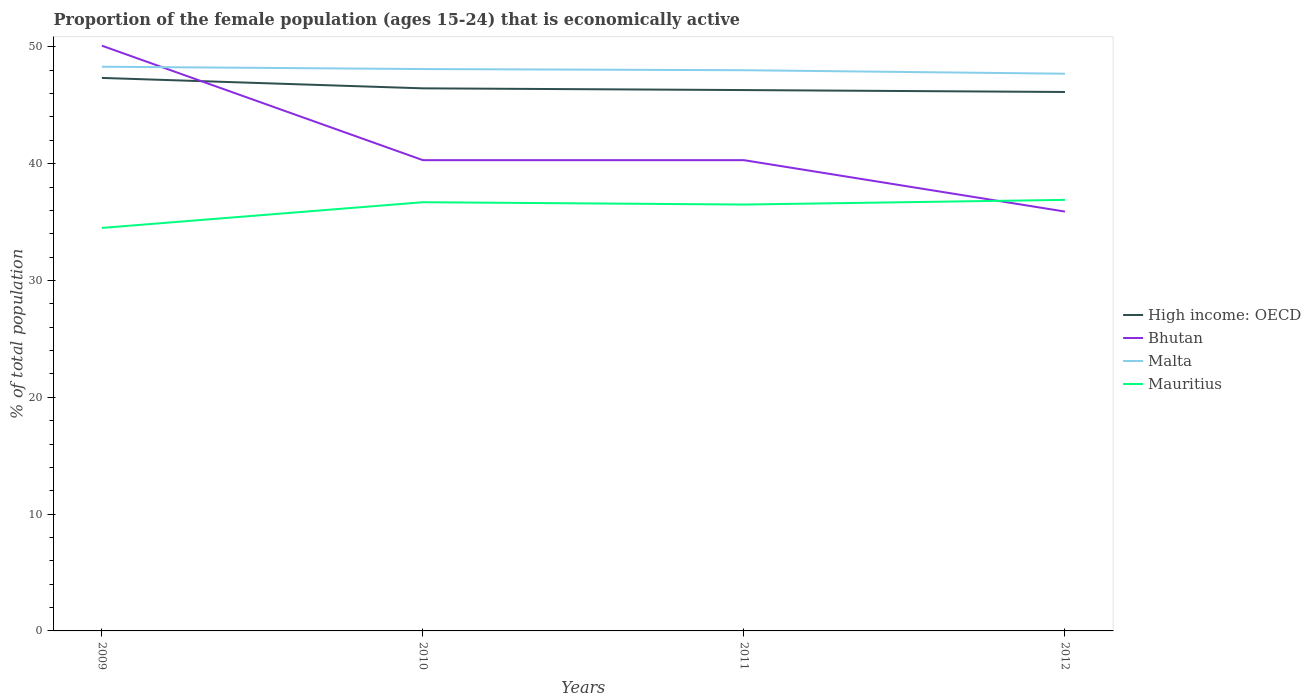How many different coloured lines are there?
Your answer should be very brief. 4. Does the line corresponding to Mauritius intersect with the line corresponding to Malta?
Provide a short and direct response. No. Across all years, what is the maximum proportion of the female population that is economically active in Mauritius?
Make the answer very short. 34.5. What is the total proportion of the female population that is economically active in Bhutan in the graph?
Your answer should be very brief. 9.8. What is the difference between the highest and the second highest proportion of the female population that is economically active in High income: OECD?
Provide a succinct answer. 1.2. Is the proportion of the female population that is economically active in Malta strictly greater than the proportion of the female population that is economically active in High income: OECD over the years?
Offer a very short reply. No. How many lines are there?
Your answer should be very brief. 4. Does the graph contain any zero values?
Your answer should be very brief. No. Where does the legend appear in the graph?
Ensure brevity in your answer.  Center right. What is the title of the graph?
Your answer should be compact. Proportion of the female population (ages 15-24) that is economically active. What is the label or title of the X-axis?
Your answer should be very brief. Years. What is the label or title of the Y-axis?
Offer a very short reply. % of total population. What is the % of total population in High income: OECD in 2009?
Provide a short and direct response. 47.34. What is the % of total population of Bhutan in 2009?
Give a very brief answer. 50.1. What is the % of total population in Malta in 2009?
Provide a succinct answer. 48.3. What is the % of total population of Mauritius in 2009?
Your answer should be very brief. 34.5. What is the % of total population in High income: OECD in 2010?
Offer a very short reply. 46.45. What is the % of total population of Bhutan in 2010?
Offer a terse response. 40.3. What is the % of total population in Malta in 2010?
Keep it short and to the point. 48.1. What is the % of total population of Mauritius in 2010?
Provide a succinct answer. 36.7. What is the % of total population in High income: OECD in 2011?
Offer a very short reply. 46.3. What is the % of total population of Bhutan in 2011?
Your answer should be very brief. 40.3. What is the % of total population in Mauritius in 2011?
Your response must be concise. 36.5. What is the % of total population of High income: OECD in 2012?
Offer a terse response. 46.14. What is the % of total population in Bhutan in 2012?
Provide a succinct answer. 35.9. What is the % of total population in Malta in 2012?
Ensure brevity in your answer.  47.7. What is the % of total population of Mauritius in 2012?
Your response must be concise. 36.9. Across all years, what is the maximum % of total population of High income: OECD?
Keep it short and to the point. 47.34. Across all years, what is the maximum % of total population of Bhutan?
Your response must be concise. 50.1. Across all years, what is the maximum % of total population in Malta?
Provide a succinct answer. 48.3. Across all years, what is the maximum % of total population of Mauritius?
Your answer should be very brief. 36.9. Across all years, what is the minimum % of total population in High income: OECD?
Offer a terse response. 46.14. Across all years, what is the minimum % of total population of Bhutan?
Provide a succinct answer. 35.9. Across all years, what is the minimum % of total population of Malta?
Ensure brevity in your answer.  47.7. Across all years, what is the minimum % of total population of Mauritius?
Make the answer very short. 34.5. What is the total % of total population of High income: OECD in the graph?
Give a very brief answer. 186.23. What is the total % of total population of Bhutan in the graph?
Keep it short and to the point. 166.6. What is the total % of total population in Malta in the graph?
Keep it short and to the point. 192.1. What is the total % of total population in Mauritius in the graph?
Keep it short and to the point. 144.6. What is the difference between the % of total population of High income: OECD in 2009 and that in 2010?
Provide a short and direct response. 0.89. What is the difference between the % of total population in High income: OECD in 2009 and that in 2011?
Make the answer very short. 1.04. What is the difference between the % of total population of High income: OECD in 2009 and that in 2012?
Your response must be concise. 1.2. What is the difference between the % of total population of Bhutan in 2009 and that in 2012?
Your response must be concise. 14.2. What is the difference between the % of total population of Mauritius in 2009 and that in 2012?
Offer a very short reply. -2.4. What is the difference between the % of total population of High income: OECD in 2010 and that in 2011?
Offer a very short reply. 0.15. What is the difference between the % of total population in Mauritius in 2010 and that in 2011?
Give a very brief answer. 0.2. What is the difference between the % of total population of High income: OECD in 2010 and that in 2012?
Your response must be concise. 0.31. What is the difference between the % of total population of Malta in 2010 and that in 2012?
Provide a succinct answer. 0.4. What is the difference between the % of total population of High income: OECD in 2011 and that in 2012?
Provide a short and direct response. 0.16. What is the difference between the % of total population of Bhutan in 2011 and that in 2012?
Give a very brief answer. 4.4. What is the difference between the % of total population of High income: OECD in 2009 and the % of total population of Bhutan in 2010?
Give a very brief answer. 7.04. What is the difference between the % of total population of High income: OECD in 2009 and the % of total population of Malta in 2010?
Provide a succinct answer. -0.76. What is the difference between the % of total population in High income: OECD in 2009 and the % of total population in Mauritius in 2010?
Ensure brevity in your answer.  10.64. What is the difference between the % of total population in Bhutan in 2009 and the % of total population in Mauritius in 2010?
Provide a short and direct response. 13.4. What is the difference between the % of total population in High income: OECD in 2009 and the % of total population in Bhutan in 2011?
Give a very brief answer. 7.04. What is the difference between the % of total population in High income: OECD in 2009 and the % of total population in Malta in 2011?
Keep it short and to the point. -0.66. What is the difference between the % of total population in High income: OECD in 2009 and the % of total population in Mauritius in 2011?
Keep it short and to the point. 10.84. What is the difference between the % of total population in Bhutan in 2009 and the % of total population in Malta in 2011?
Offer a very short reply. 2.1. What is the difference between the % of total population of Malta in 2009 and the % of total population of Mauritius in 2011?
Your response must be concise. 11.8. What is the difference between the % of total population in High income: OECD in 2009 and the % of total population in Bhutan in 2012?
Your response must be concise. 11.44. What is the difference between the % of total population of High income: OECD in 2009 and the % of total population of Malta in 2012?
Your answer should be very brief. -0.36. What is the difference between the % of total population in High income: OECD in 2009 and the % of total population in Mauritius in 2012?
Your answer should be very brief. 10.44. What is the difference between the % of total population of Bhutan in 2009 and the % of total population of Mauritius in 2012?
Provide a succinct answer. 13.2. What is the difference between the % of total population of Malta in 2009 and the % of total population of Mauritius in 2012?
Provide a succinct answer. 11.4. What is the difference between the % of total population in High income: OECD in 2010 and the % of total population in Bhutan in 2011?
Make the answer very short. 6.15. What is the difference between the % of total population of High income: OECD in 2010 and the % of total population of Malta in 2011?
Your answer should be very brief. -1.55. What is the difference between the % of total population of High income: OECD in 2010 and the % of total population of Mauritius in 2011?
Offer a terse response. 9.95. What is the difference between the % of total population in Bhutan in 2010 and the % of total population in Mauritius in 2011?
Your answer should be very brief. 3.8. What is the difference between the % of total population of High income: OECD in 2010 and the % of total population of Bhutan in 2012?
Your answer should be compact. 10.55. What is the difference between the % of total population in High income: OECD in 2010 and the % of total population in Malta in 2012?
Your response must be concise. -1.25. What is the difference between the % of total population in High income: OECD in 2010 and the % of total population in Mauritius in 2012?
Make the answer very short. 9.55. What is the difference between the % of total population of Bhutan in 2010 and the % of total population of Mauritius in 2012?
Offer a very short reply. 3.4. What is the difference between the % of total population of High income: OECD in 2011 and the % of total population of Bhutan in 2012?
Your answer should be compact. 10.4. What is the difference between the % of total population of High income: OECD in 2011 and the % of total population of Malta in 2012?
Offer a very short reply. -1.4. What is the difference between the % of total population in High income: OECD in 2011 and the % of total population in Mauritius in 2012?
Keep it short and to the point. 9.4. What is the difference between the % of total population of Bhutan in 2011 and the % of total population of Mauritius in 2012?
Offer a very short reply. 3.4. What is the average % of total population in High income: OECD per year?
Ensure brevity in your answer.  46.56. What is the average % of total population in Bhutan per year?
Make the answer very short. 41.65. What is the average % of total population in Malta per year?
Make the answer very short. 48.02. What is the average % of total population in Mauritius per year?
Your response must be concise. 36.15. In the year 2009, what is the difference between the % of total population of High income: OECD and % of total population of Bhutan?
Make the answer very short. -2.76. In the year 2009, what is the difference between the % of total population of High income: OECD and % of total population of Malta?
Ensure brevity in your answer.  -0.96. In the year 2009, what is the difference between the % of total population in High income: OECD and % of total population in Mauritius?
Make the answer very short. 12.84. In the year 2009, what is the difference between the % of total population of Bhutan and % of total population of Malta?
Keep it short and to the point. 1.8. In the year 2009, what is the difference between the % of total population of Malta and % of total population of Mauritius?
Make the answer very short. 13.8. In the year 2010, what is the difference between the % of total population in High income: OECD and % of total population in Bhutan?
Make the answer very short. 6.15. In the year 2010, what is the difference between the % of total population in High income: OECD and % of total population in Malta?
Offer a very short reply. -1.65. In the year 2010, what is the difference between the % of total population in High income: OECD and % of total population in Mauritius?
Provide a short and direct response. 9.75. In the year 2010, what is the difference between the % of total population in Bhutan and % of total population in Malta?
Your answer should be very brief. -7.8. In the year 2010, what is the difference between the % of total population of Malta and % of total population of Mauritius?
Give a very brief answer. 11.4. In the year 2011, what is the difference between the % of total population in High income: OECD and % of total population in Bhutan?
Your answer should be compact. 6. In the year 2011, what is the difference between the % of total population of High income: OECD and % of total population of Malta?
Your answer should be very brief. -1.7. In the year 2011, what is the difference between the % of total population of High income: OECD and % of total population of Mauritius?
Your response must be concise. 9.8. In the year 2011, what is the difference between the % of total population of Bhutan and % of total population of Malta?
Make the answer very short. -7.7. In the year 2011, what is the difference between the % of total population in Bhutan and % of total population in Mauritius?
Give a very brief answer. 3.8. In the year 2012, what is the difference between the % of total population in High income: OECD and % of total population in Bhutan?
Your answer should be compact. 10.24. In the year 2012, what is the difference between the % of total population in High income: OECD and % of total population in Malta?
Your response must be concise. -1.56. In the year 2012, what is the difference between the % of total population of High income: OECD and % of total population of Mauritius?
Make the answer very short. 9.24. What is the ratio of the % of total population of High income: OECD in 2009 to that in 2010?
Offer a terse response. 1.02. What is the ratio of the % of total population of Bhutan in 2009 to that in 2010?
Your response must be concise. 1.24. What is the ratio of the % of total population of Malta in 2009 to that in 2010?
Make the answer very short. 1. What is the ratio of the % of total population of Mauritius in 2009 to that in 2010?
Your answer should be very brief. 0.94. What is the ratio of the % of total population in High income: OECD in 2009 to that in 2011?
Offer a very short reply. 1.02. What is the ratio of the % of total population in Bhutan in 2009 to that in 2011?
Keep it short and to the point. 1.24. What is the ratio of the % of total population in Malta in 2009 to that in 2011?
Make the answer very short. 1.01. What is the ratio of the % of total population of Mauritius in 2009 to that in 2011?
Your answer should be very brief. 0.95. What is the ratio of the % of total population in High income: OECD in 2009 to that in 2012?
Offer a very short reply. 1.03. What is the ratio of the % of total population of Bhutan in 2009 to that in 2012?
Your answer should be very brief. 1.4. What is the ratio of the % of total population in Malta in 2009 to that in 2012?
Give a very brief answer. 1.01. What is the ratio of the % of total population in Mauritius in 2009 to that in 2012?
Provide a short and direct response. 0.94. What is the ratio of the % of total population in Mauritius in 2010 to that in 2011?
Your answer should be compact. 1.01. What is the ratio of the % of total population of Bhutan in 2010 to that in 2012?
Offer a terse response. 1.12. What is the ratio of the % of total population of Malta in 2010 to that in 2012?
Make the answer very short. 1.01. What is the ratio of the % of total population in Bhutan in 2011 to that in 2012?
Your answer should be compact. 1.12. What is the ratio of the % of total population of Malta in 2011 to that in 2012?
Ensure brevity in your answer.  1.01. What is the difference between the highest and the second highest % of total population of High income: OECD?
Your answer should be compact. 0.89. What is the difference between the highest and the second highest % of total population of Mauritius?
Ensure brevity in your answer.  0.2. What is the difference between the highest and the lowest % of total population in High income: OECD?
Provide a succinct answer. 1.2. What is the difference between the highest and the lowest % of total population in Bhutan?
Your answer should be very brief. 14.2. What is the difference between the highest and the lowest % of total population of Malta?
Your response must be concise. 0.6. What is the difference between the highest and the lowest % of total population in Mauritius?
Keep it short and to the point. 2.4. 